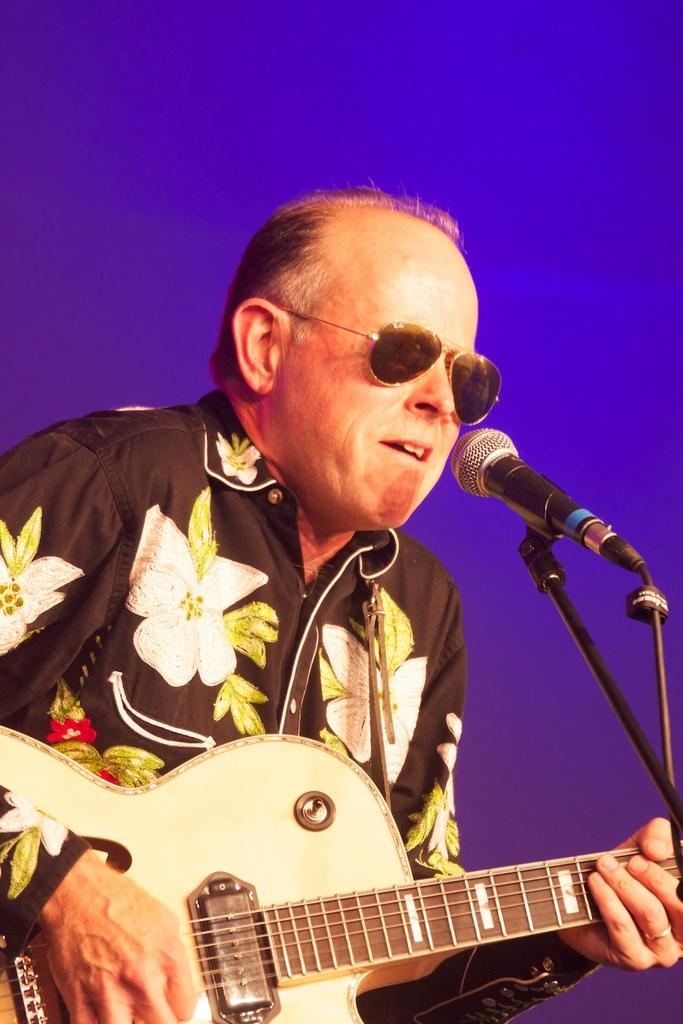What is the man in the image doing? The man is singing and playing the guitar. What object is the man holding in the image? The man is holding a microphone. How is the man producing sound in the image? The man is singing and playing the guitar to produce sound. What is the weight of the root that the man is holding in the image? There is no root present in the image; the man is holding a microphone and playing the guitar. 